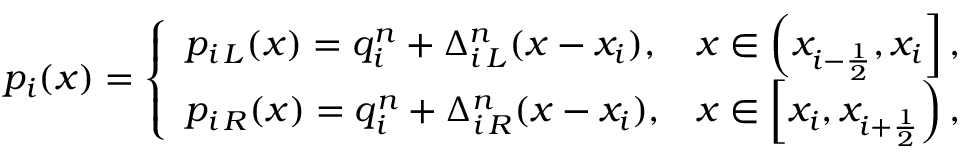<formula> <loc_0><loc_0><loc_500><loc_500>p _ { i } ( x ) = \left \{ \begin{array} { l r } { p _ { i \, L } ( x ) = q _ { i } ^ { n } + \Delta _ { i \, L } ^ { n } ( x - x _ { i } ) , } & { x \in \left ( x _ { i - \frac { 1 } { 2 } } , x _ { i } \right ] , } \\ { p _ { i \, R } ( x ) = q _ { i } ^ { n } + \Delta _ { i \, R } ^ { n } ( x - x _ { i } ) , } & { x \in \left [ x _ { i } , x _ { i + \frac { 1 } { 2 } } \right ) , } \end{array}</formula> 